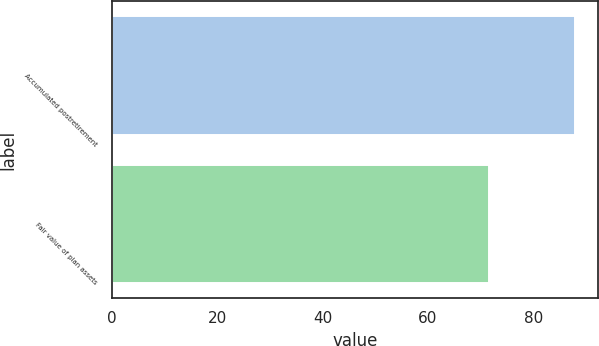Convert chart. <chart><loc_0><loc_0><loc_500><loc_500><bar_chart><fcel>Accumulated postretirement<fcel>Fair value of plan assets<nl><fcel>87.9<fcel>71.6<nl></chart> 